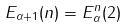<formula> <loc_0><loc_0><loc_500><loc_500>E _ { \alpha + 1 } ( n ) = E _ { \alpha } ^ { n } ( 2 )</formula> 